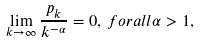Convert formula to latex. <formula><loc_0><loc_0><loc_500><loc_500>\lim _ { k \rightarrow \infty } \frac { p _ { k } } { k ^ { - \alpha } } = 0 , \, f o r a l l \alpha > 1 ,</formula> 